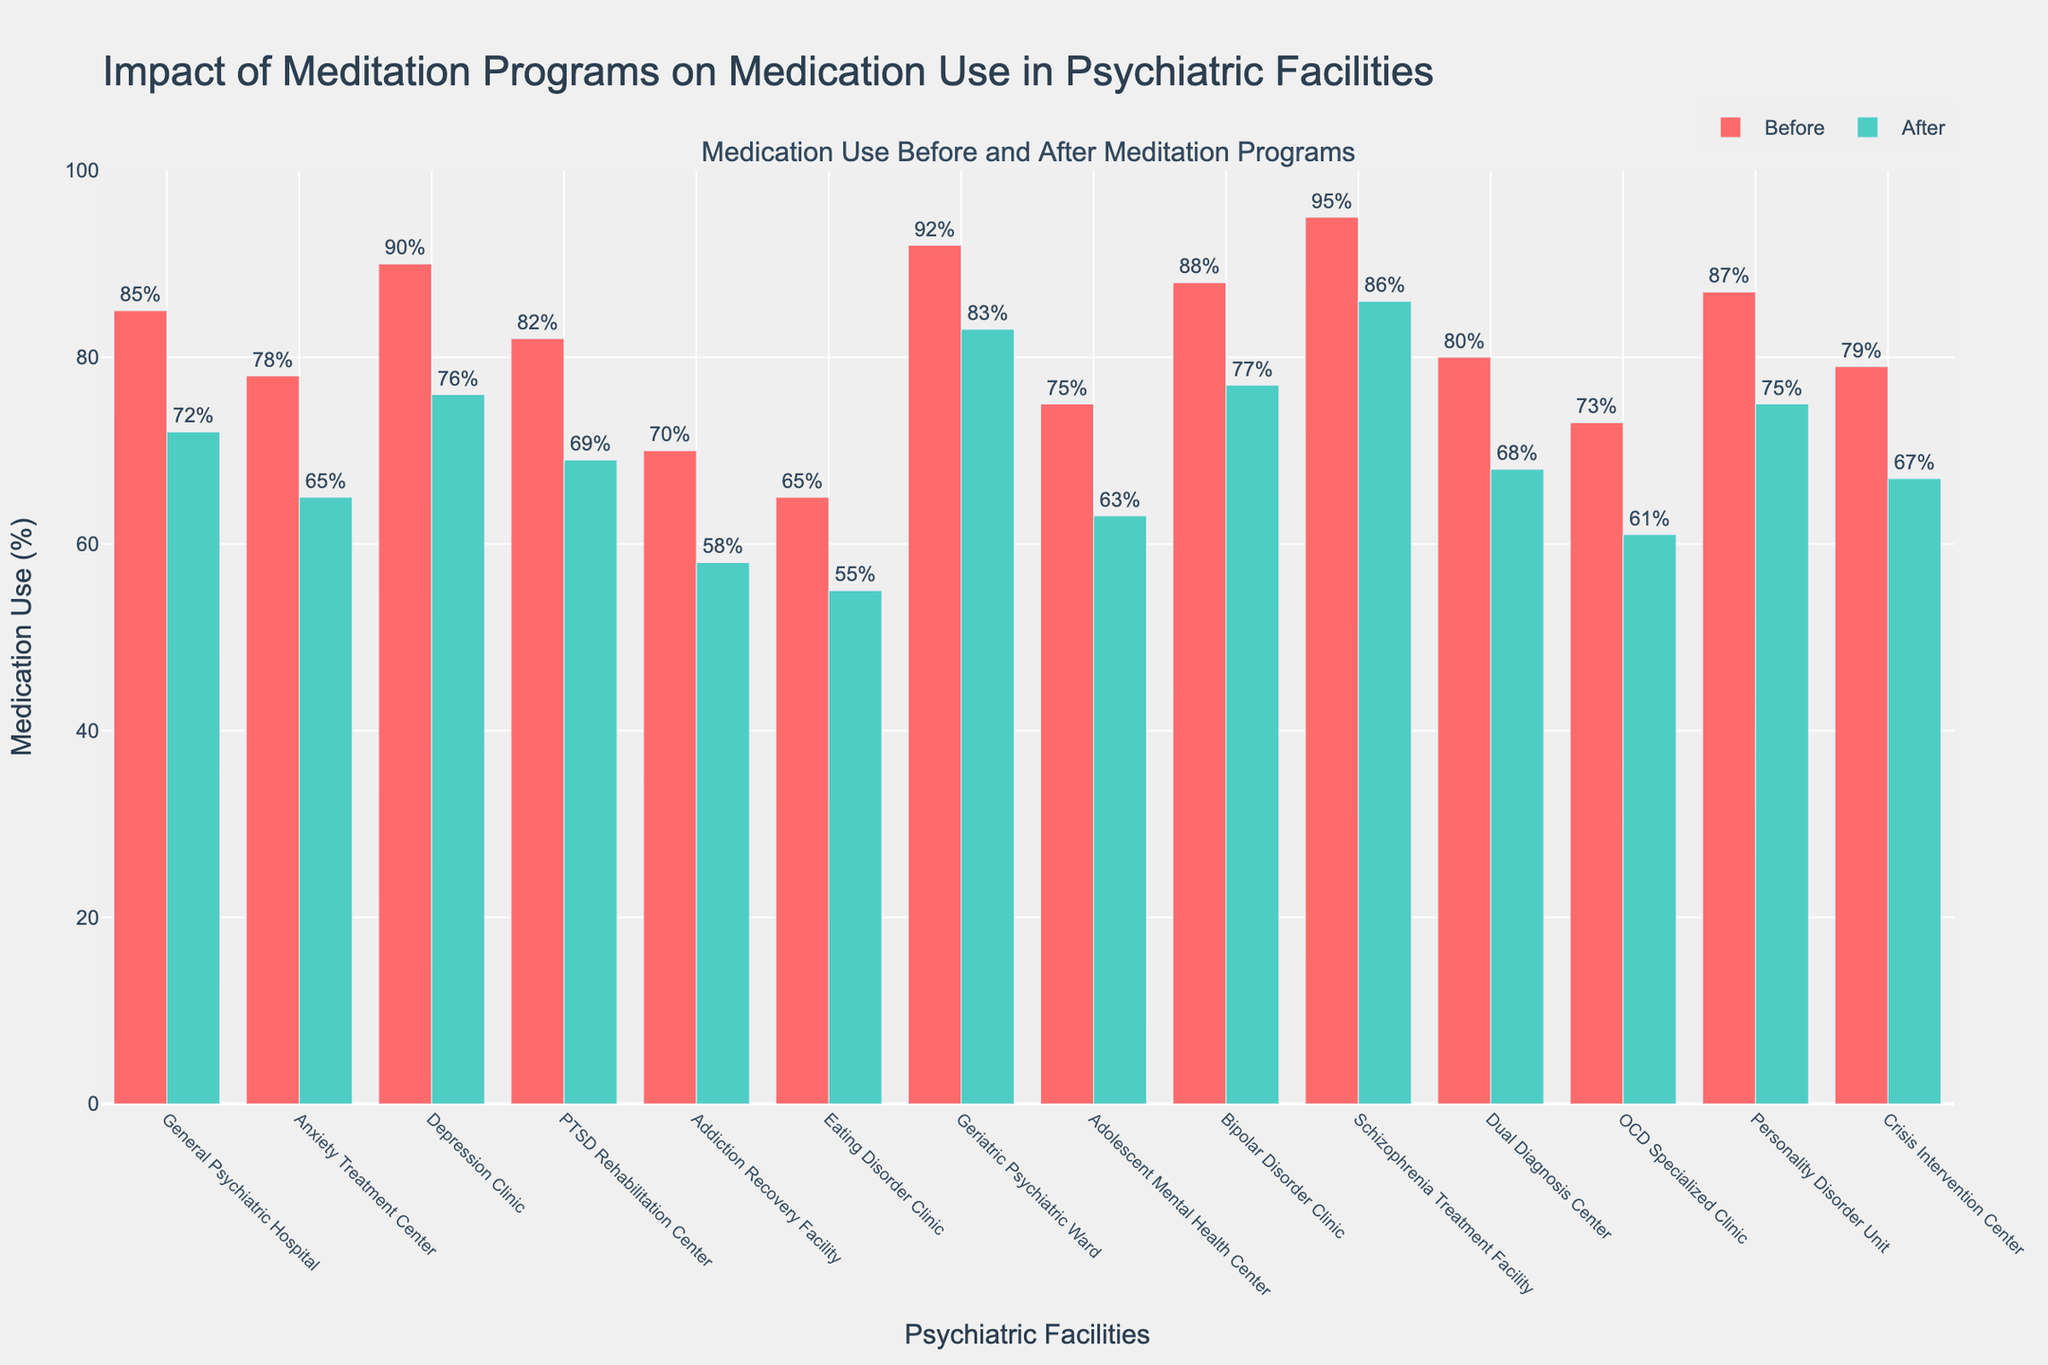What is the difference in medication use before and after implementing meditation programs in the Schizophrenia Treatment Facility? To find the difference, subtract the medication use after from the medication use before: 95 - 86.
Answer: 9 Which facility experienced the greatest reduction in medication use after implementing meditation programs? Compare the differences in medication use before and after for all facilities: Subtract 'Medication_Use_After' from 'Medication_Use_Before' for each facility and identify the largest difference. The General Psychiatric Hospital has the largest reduction: 85 - 72 = 13.
Answer: General Psychiatric Hospital What is the total medication use for all facilities before the implementation of meditation programs? Sum the medication use before for all facilities: 85 + 78 + 90 + 82 + 70 + 65 + 92 + 75 + 88 + 95 + 80 + 73 + 87 + 79.
Answer: 1139 Among all facilities, which two have the closest values for medication use after implementing meditation programs? Evaluate the medication use after values and identify the two facilities with the smallest difference between them. The Bipolar Disorder Clinic and the Geriatric Psychiatric Ward both have very close values: 77 and 83, respectively. The difference is 6.
Answer: Bipolar Disorder Clinic and Geriatric Psychiatric Ward What is the average reduction in medication use across all facilities after implementing meditation programs? Calculate the difference for each facility (subtract 'Medication_Use_After' from 'Medication_Use_Before'), sum these differences, and divide by the number of facilities to find the average: (13 + 13 + 14 + 13 + 12 + 10 + 9 + 12 + 11 + 9 + 12 + 12 + 12 + 12) / 14.
Answer: 11.57 Which facility had the highest medication use before the implementation of meditation programs? Identify the facility with the highest value in the 'Medication_Use_Before' column. The Schizophrenia Treatment Facility has the highest medication use before, 95.
Answer: Schizophrenia Treatment Facility Did any facility have an increase in medication use after implementing meditation programs? Examine the figure to see if any 'Medication_Use_After' bars are higher than the corresponding 'Medication_Use_Before' bars. There is no facility that experienced an increase.
Answer: No 